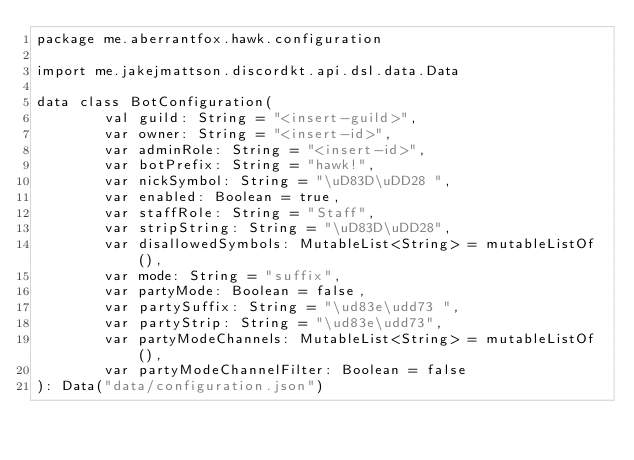Convert code to text. <code><loc_0><loc_0><loc_500><loc_500><_Kotlin_>package me.aberrantfox.hawk.configuration

import me.jakejmattson.discordkt.api.dsl.data.Data

data class BotConfiguration(
        val guild: String = "<insert-guild>",
        var owner: String = "<insert-id>",
        var adminRole: String = "<insert-id>",
        var botPrefix: String = "hawk!",
        var nickSymbol: String = "\uD83D\uDD28 ",
        var enabled: Boolean = true,
        var staffRole: String = "Staff",
        var stripString: String = "\uD83D\uDD28",
        var disallowedSymbols: MutableList<String> = mutableListOf(),
        var mode: String = "suffix",
        var partyMode: Boolean = false,
        var partySuffix: String = "\ud83e\udd73 ",
        var partyStrip: String = "\ud83e\udd73",
        var partyModeChannels: MutableList<String> = mutableListOf(),
        var partyModeChannelFilter: Boolean = false
): Data("data/configuration.json")</code> 